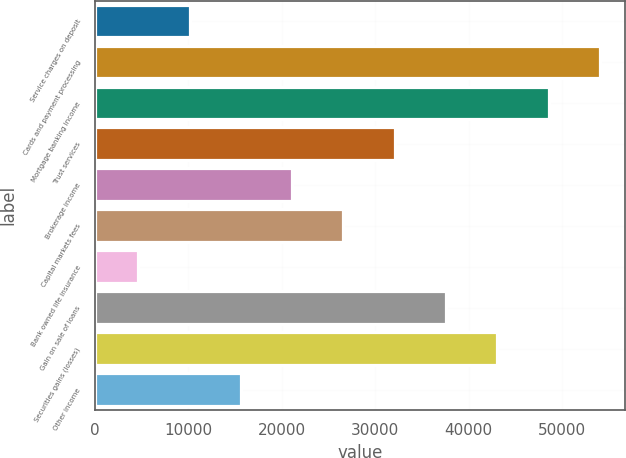<chart> <loc_0><loc_0><loc_500><loc_500><bar_chart><fcel>Service charges on deposit<fcel>Cards and payment processing<fcel>Mortgage banking income<fcel>Trust services<fcel>Brokerage income<fcel>Capital markets fees<fcel>Bank owned life insurance<fcel>Gain on sale of loans<fcel>Securities gains (losses)<fcel>Other income<nl><fcel>10138.3<fcel>54060.7<fcel>48570.4<fcel>32099.5<fcel>21118.9<fcel>26609.2<fcel>4648<fcel>37589.8<fcel>43080.1<fcel>15628.6<nl></chart> 